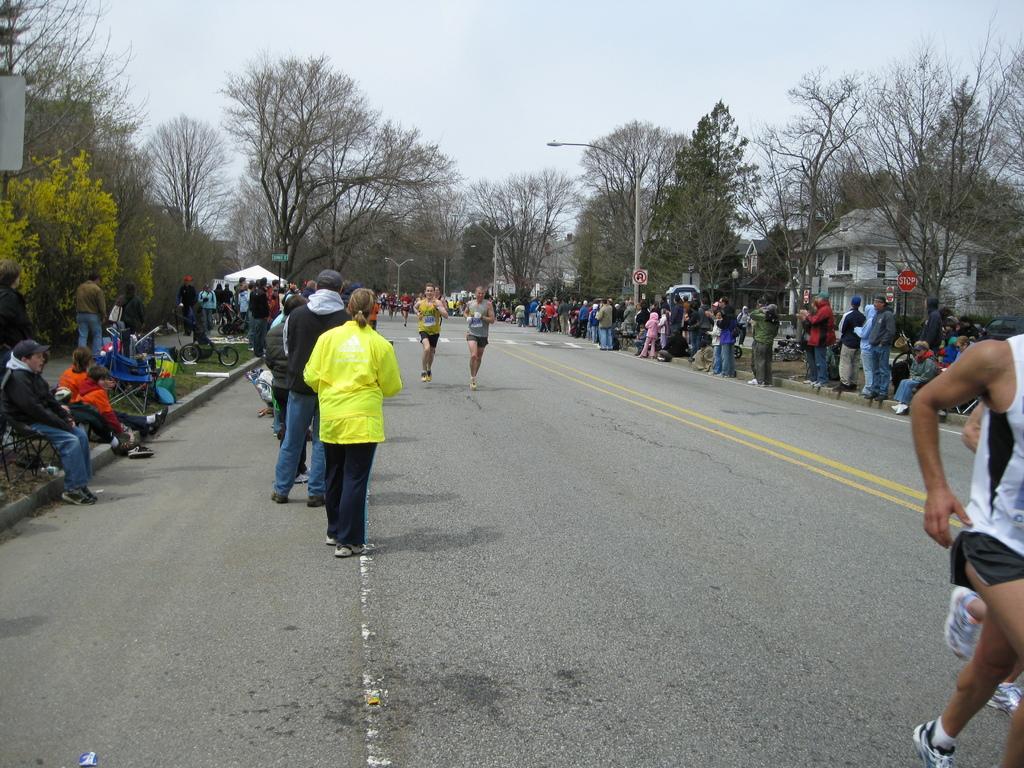Describe this image in one or two sentences. There are few people running on the road. In the background there are few people standing on the road and on the left few persons are sitting and we can also see tents,houses,trees,sign boards and sky. 